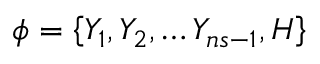Convert formula to latex. <formula><loc_0><loc_0><loc_500><loc_500>\phi = \left \{ Y _ { 1 } , Y _ { 2 } , \dots Y _ { n s - 1 } , H \right \}</formula> 